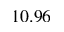Convert formula to latex. <formula><loc_0><loc_0><loc_500><loc_500>1 0 . 9 6</formula> 